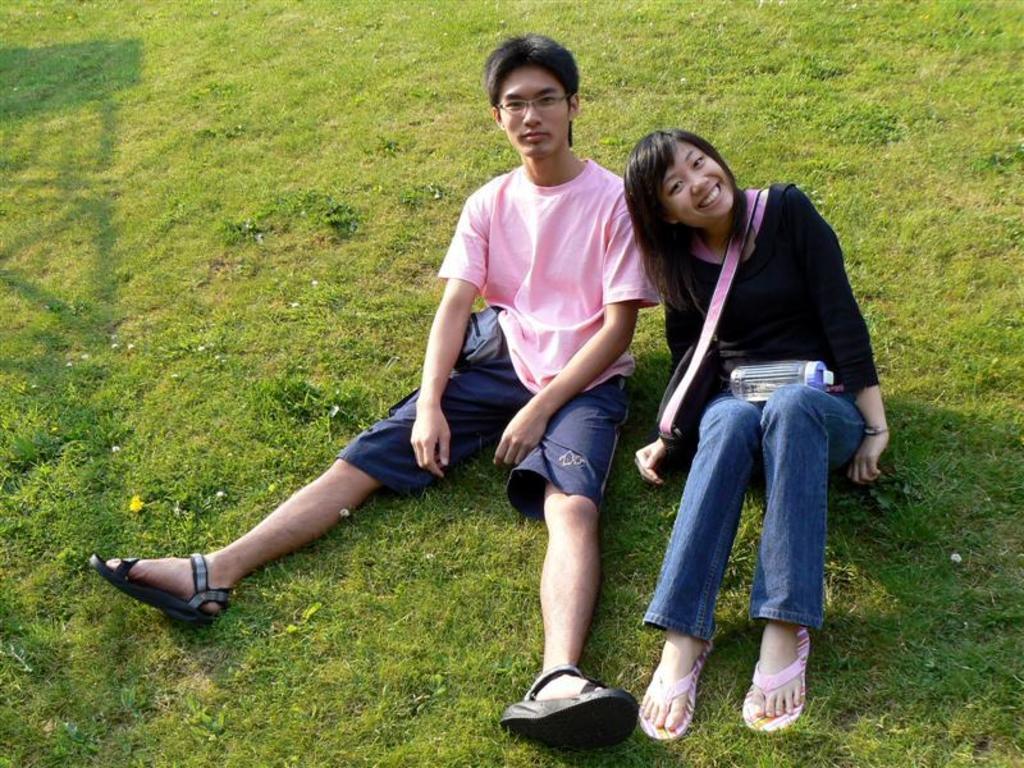Can you describe this image briefly? In this image there is a man and a girl sitting on the grass. There is a bottle and a bag. 